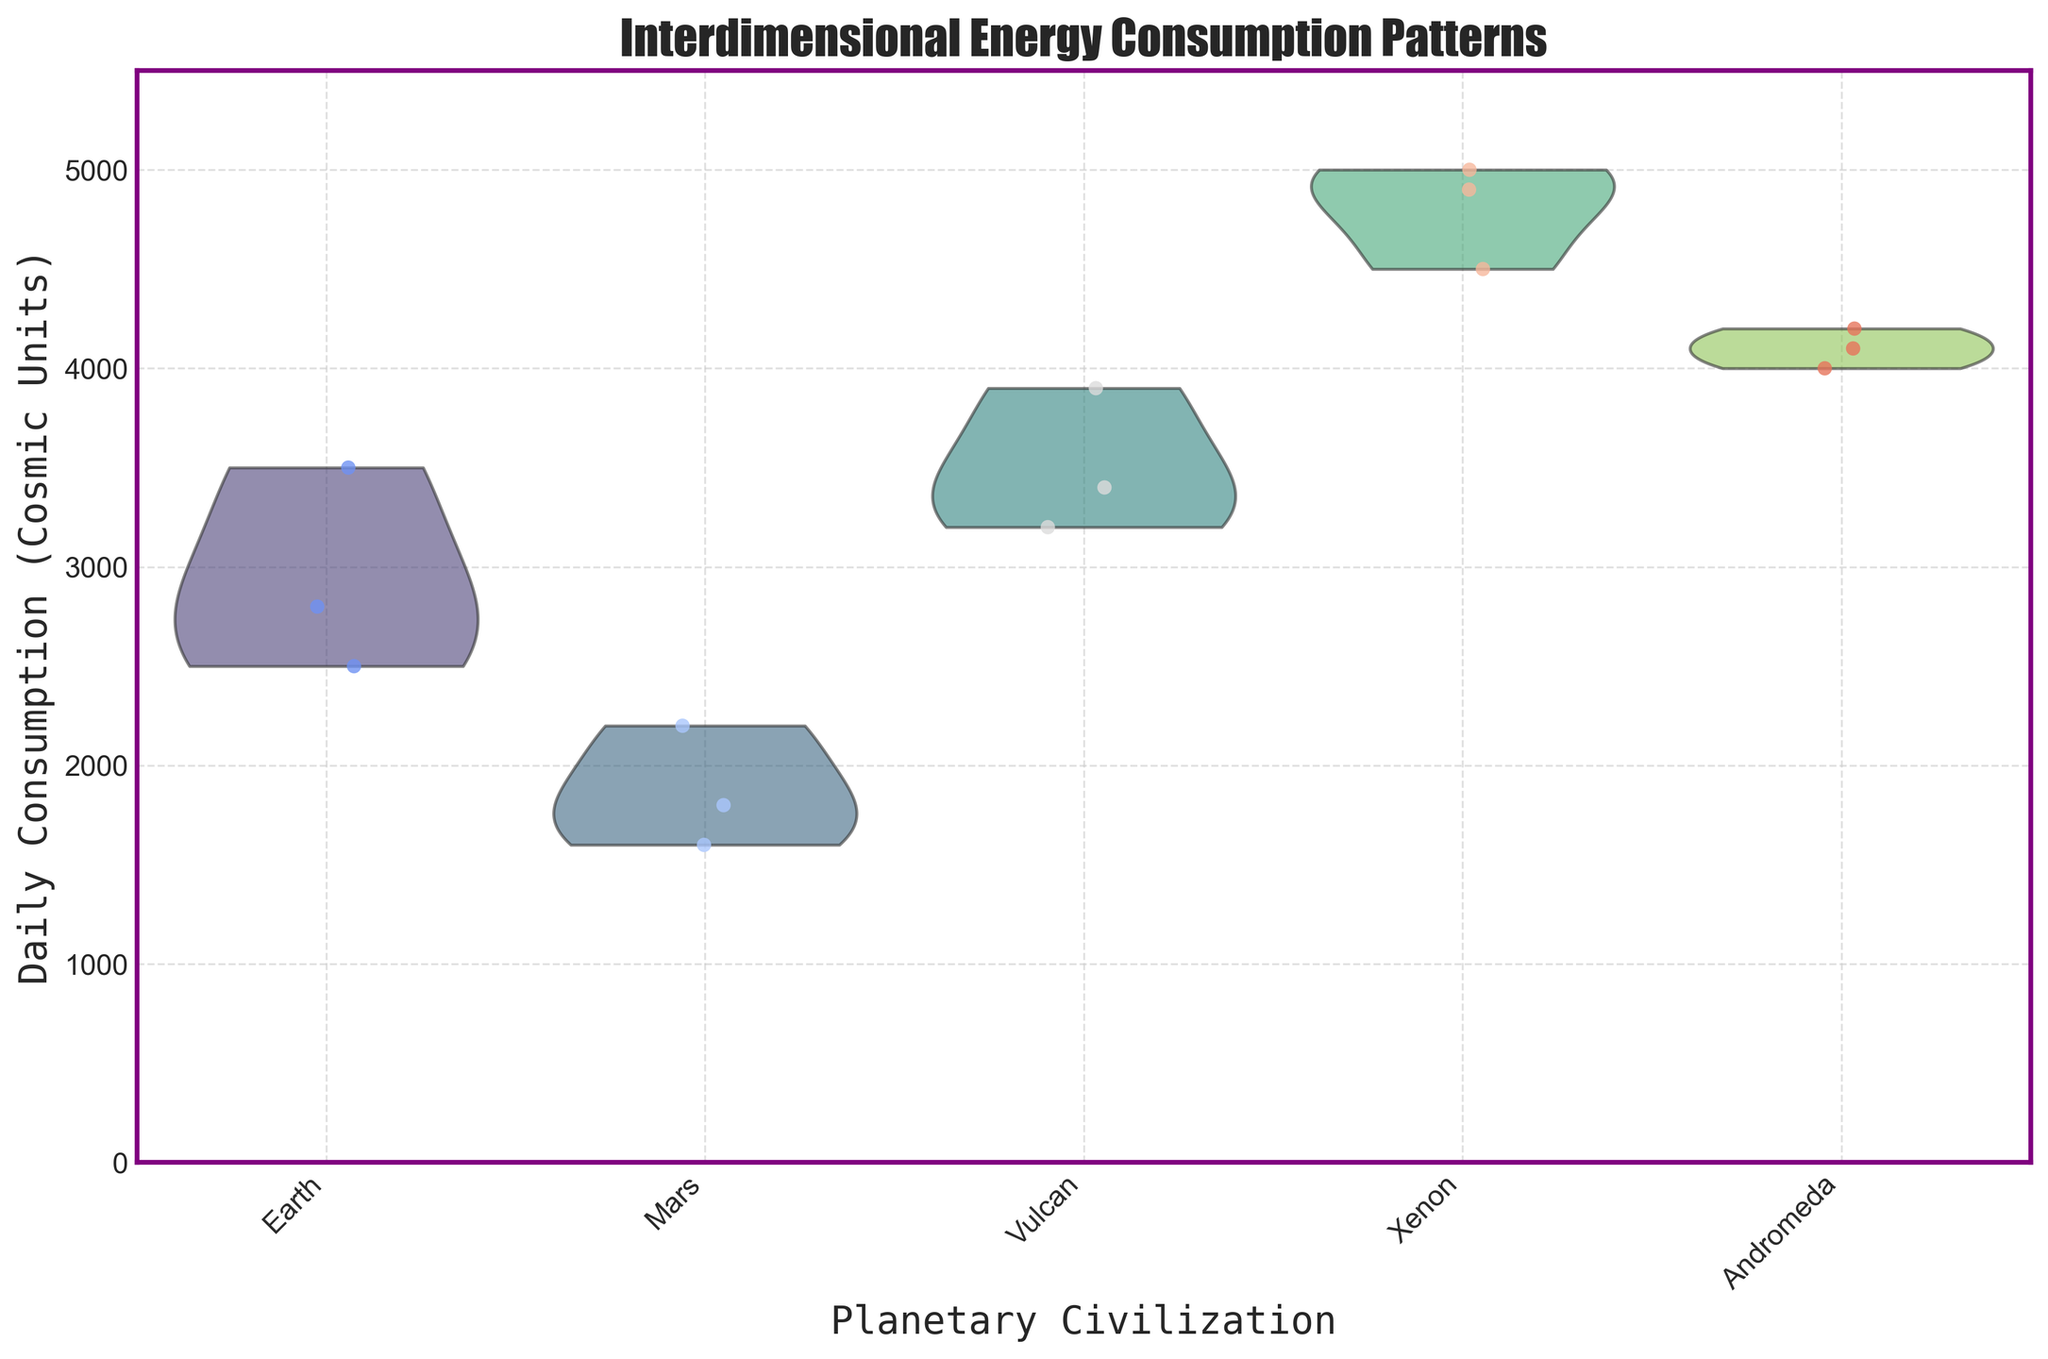What is the title of the figure? The title of the figure is displayed at the top.
Answer: Interdimensional Energy Consumption Patterns Which planetary civilization has the highest median daily consumption? By examining the width of the violin plot and the distribution of jittered points, we can infer the median value. The Xenon civilization has the widest region near the higher end of the consumption scale, indicating the highest median.
Answer: Xenon What is the daily energy consumption range for Earth? The range can be determined by looking at the top and bottom of the violin plot for Earth. The lowest point is 2500 and the highest is 3500.
Answer: 2500 to 3500 Compare the average daily consumption between Mars and Vulcan. First, identify the data points for Mars (1800, 2200, 1600) and Vulcan (3400, 3900, 3200). Compute the mean for both: Mars (1800 + 2200 + 1600) / 3 = 1867, Vulcan (3400 + 3900 + 3200) / 3 = 3500.
Answer: Mars: 1867, Vulcan: 3500 Which planetary civilization has the most spread out daily consumption values? By examining the violin plot widths and distributions, Xenon's plot appears to be the most elongated, indicating the most spread out values from 4500 to 5000.
Answer: Xenon What is the median daily consumption for Andromeda? The median lies at the mid-point of the violin plot. For Andromeda, the violin plot appears balanced around 4100.
Answer: 4100 Between Mars and Vulcan, which civilization has the lowest energy consumption? Looking at the individual jittered points, Mars has values with the minimum at 1600 compared to Vulcan's minimum at 3200.
Answer: Mars Calculate the interquartile range of daily consumption for Xenon. The interquartile range spans from the lower quartile (4500) to the upper quartile (4900). Hence, the IQR = 4900 - 4500 = 400.
Answer: 400 Which planetary civilization uses the diverse forms of energy? Visual inspection of the jittered points shows Andromeda and Xenon have three diverse energy forms represented by distinct data points, but Xenon’s forms are very close in their values, whereas Andromeda’s forms are more spread out.
Answer: Andromeda What is the daily consumption difference between the maximum value of Earth and the minimum value of Vulcan? The maximum value for Earth is 3500 and the minimum for Vulcan is 3200. Compute the difference as 3500 - 3200 = 300.
Answer: 300 